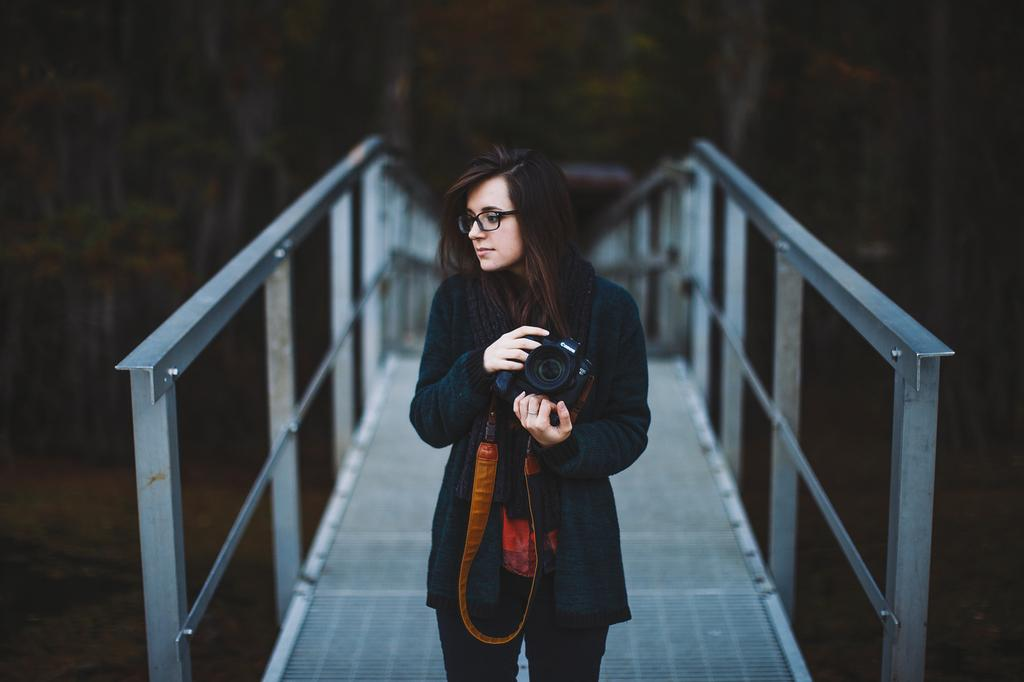Who is the main subject in the image? There is a woman in the image. What is the woman holding in the image? The woman is holding a camera. Where is the woman standing in the image? The woman is standing on a bridge. What type of wine is the woman drinking while standing on the bridge? There is no wine present in the image; the woman is holding a camera. 